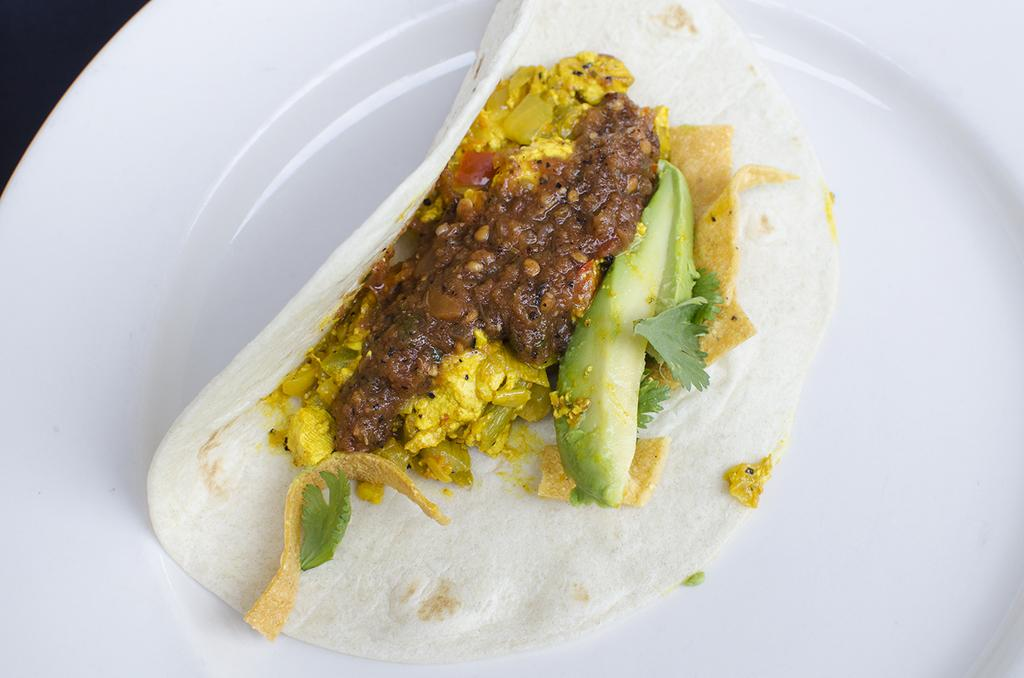What is the main food item visible in the image? There is a taco in the image. How is the taco positioned in the image? The taco is in a plate. Where is the plate with the taco located? The plate with the taco is placed on a table. How many legs can be seen supporting the table in the image? There is no information about the table's legs in the image. What part of the taco is made of lettuce? The image does not provide enough detail to determine which part of the taco is made of lettuce. 